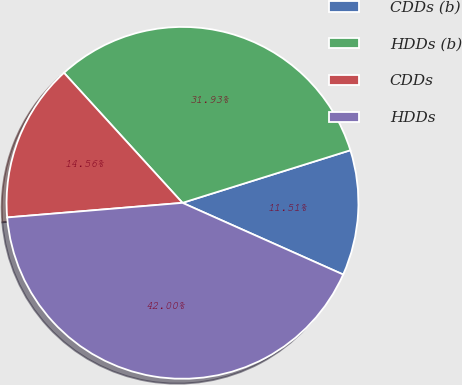Convert chart to OTSL. <chart><loc_0><loc_0><loc_500><loc_500><pie_chart><fcel>CDDs (b)<fcel>HDDs (b)<fcel>CDDs<fcel>HDDs<nl><fcel>11.51%<fcel>31.93%<fcel>14.56%<fcel>42.0%<nl></chart> 